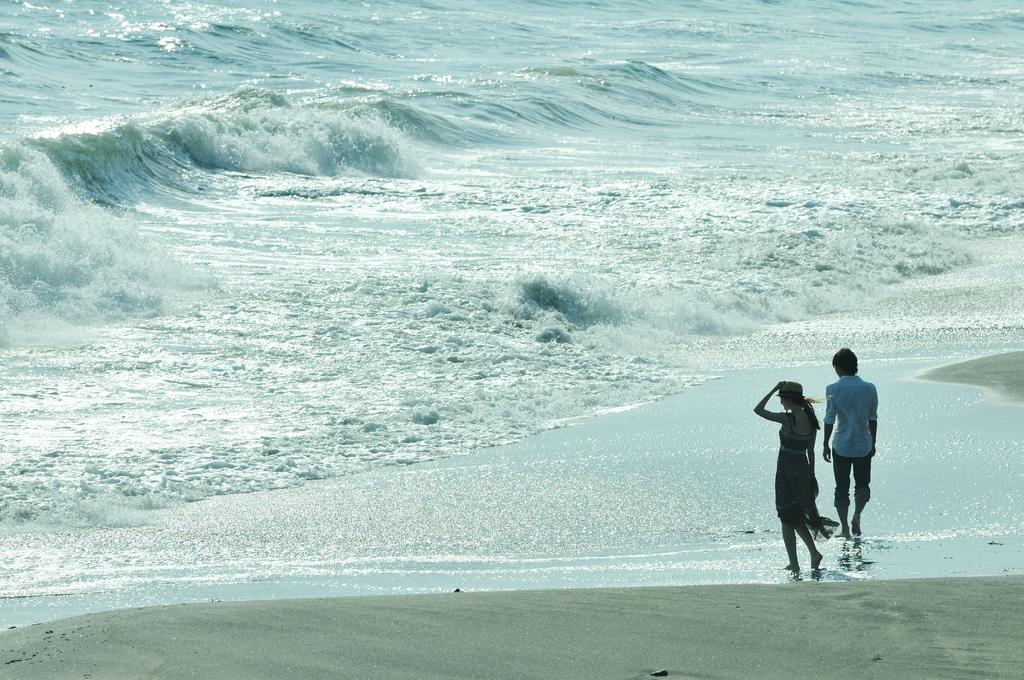How many people are in the image? There are two members in the image. What are the two members doing in the image? The two members are walking. Where is the location of the image? The location is a beach. Which side of the image is the beach on? The beach is on the right side of the image. What can be seen in the background of the image? There is an ocean in the background of the image. What type of muscle is being flexed by the person on the left side of the image? There is no muscle being flexed in the image, as the two members are walking. What is being carried in the sack on the person's back in the image? There is no sack or any object being carried on anyone's back in the image. 